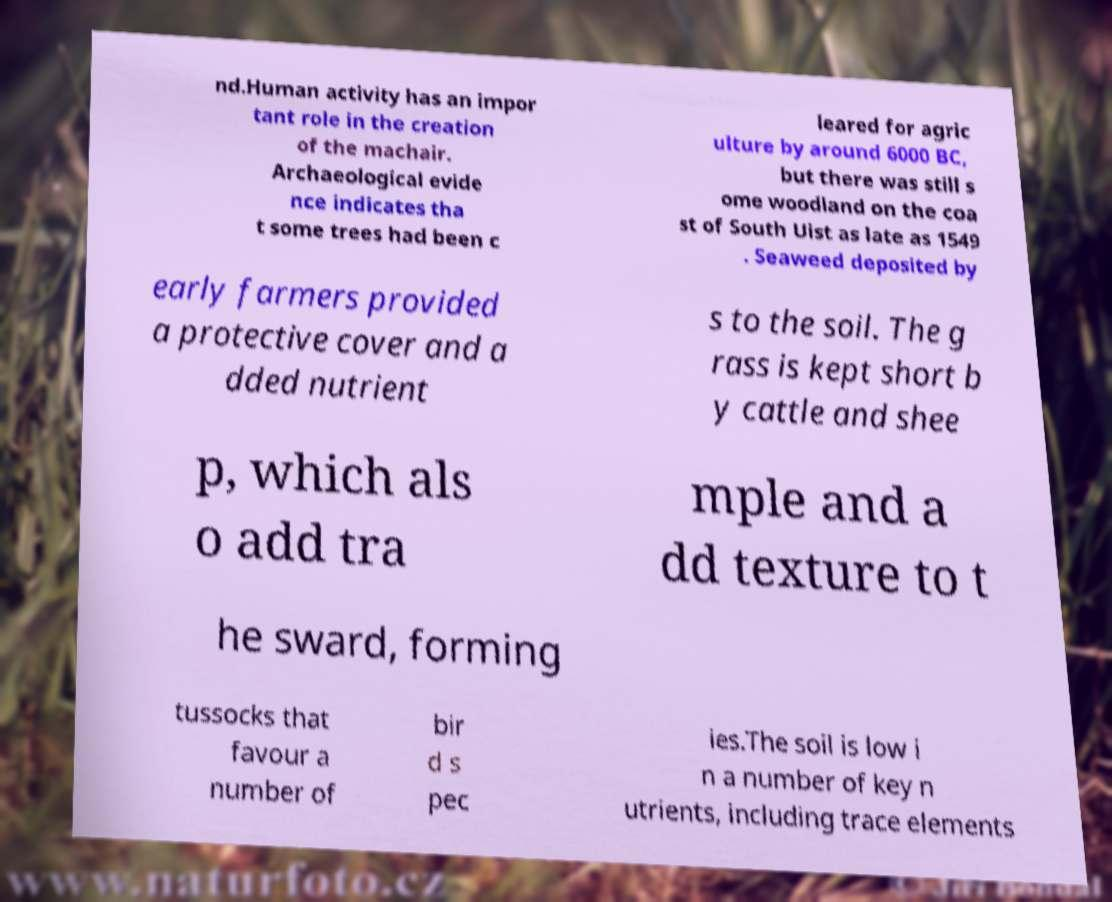Please identify and transcribe the text found in this image. nd.Human activity has an impor tant role in the creation of the machair. Archaeological evide nce indicates tha t some trees had been c leared for agric ulture by around 6000 BC, but there was still s ome woodland on the coa st of South Uist as late as 1549 . Seaweed deposited by early farmers provided a protective cover and a dded nutrient s to the soil. The g rass is kept short b y cattle and shee p, which als o add tra mple and a dd texture to t he sward, forming tussocks that favour a number of bir d s pec ies.The soil is low i n a number of key n utrients, including trace elements 